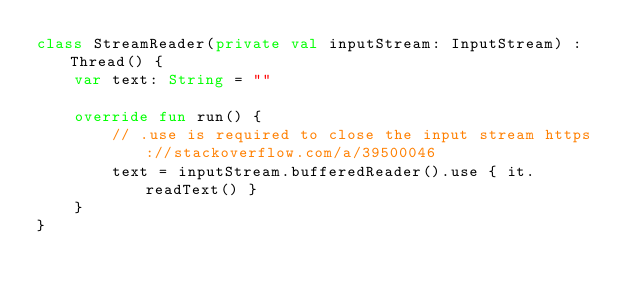<code> <loc_0><loc_0><loc_500><loc_500><_Kotlin_>class StreamReader(private val inputStream: InputStream) : Thread() {
    var text: String = ""

    override fun run() {
        // .use is required to close the input stream https://stackoverflow.com/a/39500046
        text = inputStream.bufferedReader().use { it.readText() }
    }
}
</code> 